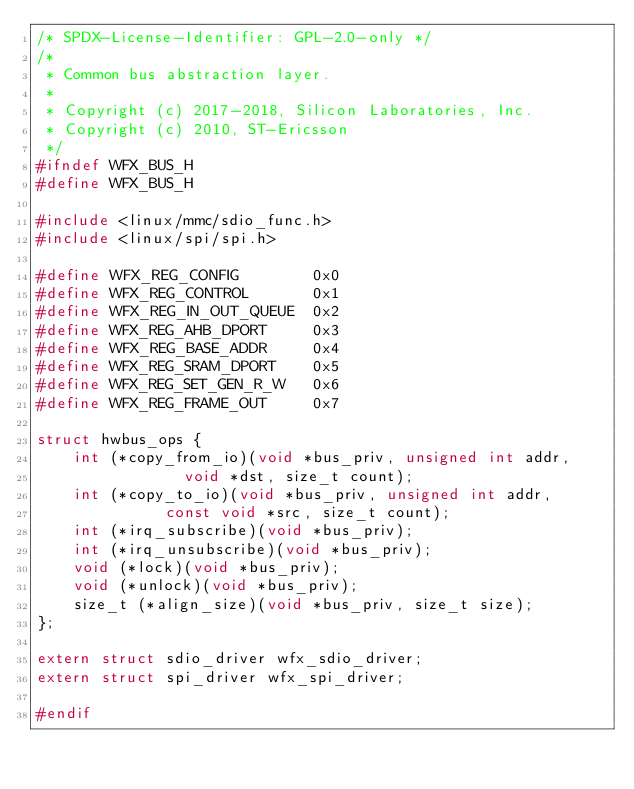<code> <loc_0><loc_0><loc_500><loc_500><_C_>/* SPDX-License-Identifier: GPL-2.0-only */
/*
 * Common bus abstraction layer.
 *
 * Copyright (c) 2017-2018, Silicon Laboratories, Inc.
 * Copyright (c) 2010, ST-Ericsson
 */
#ifndef WFX_BUS_H
#define WFX_BUS_H

#include <linux/mmc/sdio_func.h>
#include <linux/spi/spi.h>

#define WFX_REG_CONFIG        0x0
#define WFX_REG_CONTROL       0x1
#define WFX_REG_IN_OUT_QUEUE  0x2
#define WFX_REG_AHB_DPORT     0x3
#define WFX_REG_BASE_ADDR     0x4
#define WFX_REG_SRAM_DPORT    0x5
#define WFX_REG_SET_GEN_R_W   0x6
#define WFX_REG_FRAME_OUT     0x7

struct hwbus_ops {
	int (*copy_from_io)(void *bus_priv, unsigned int addr,
			    void *dst, size_t count);
	int (*copy_to_io)(void *bus_priv, unsigned int addr,
			  const void *src, size_t count);
	int (*irq_subscribe)(void *bus_priv);
	int (*irq_unsubscribe)(void *bus_priv);
	void (*lock)(void *bus_priv);
	void (*unlock)(void *bus_priv);
	size_t (*align_size)(void *bus_priv, size_t size);
};

extern struct sdio_driver wfx_sdio_driver;
extern struct spi_driver wfx_spi_driver;

#endif
</code> 